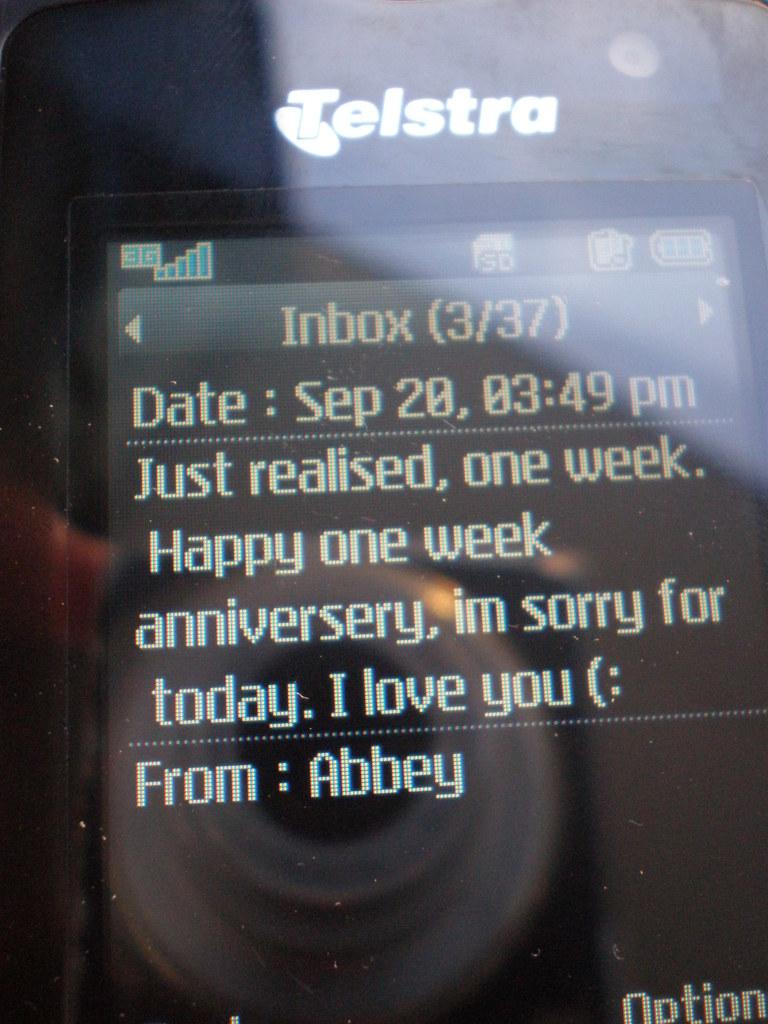<image>
Relay a brief, clear account of the picture shown. A Telstra device with an anniversary message on it. 